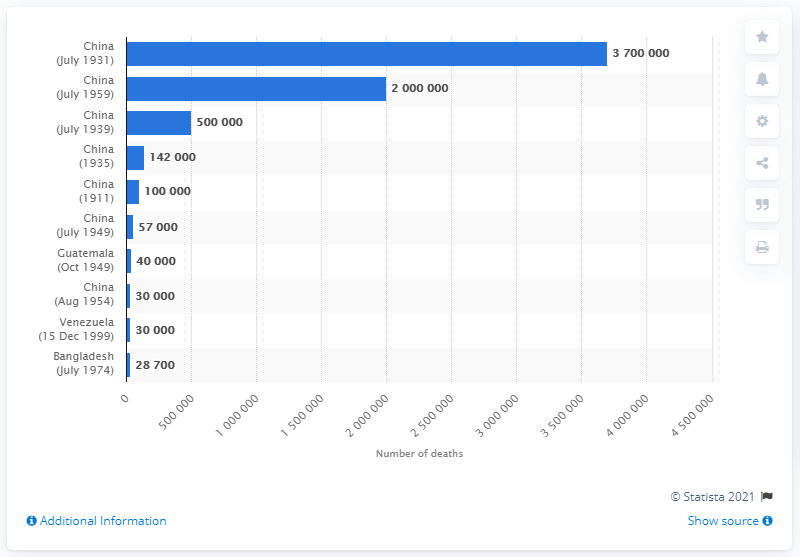Identify some key points in this picture. The floods in China in July 1931 resulted in the deaths of approximately 3700000 people. 